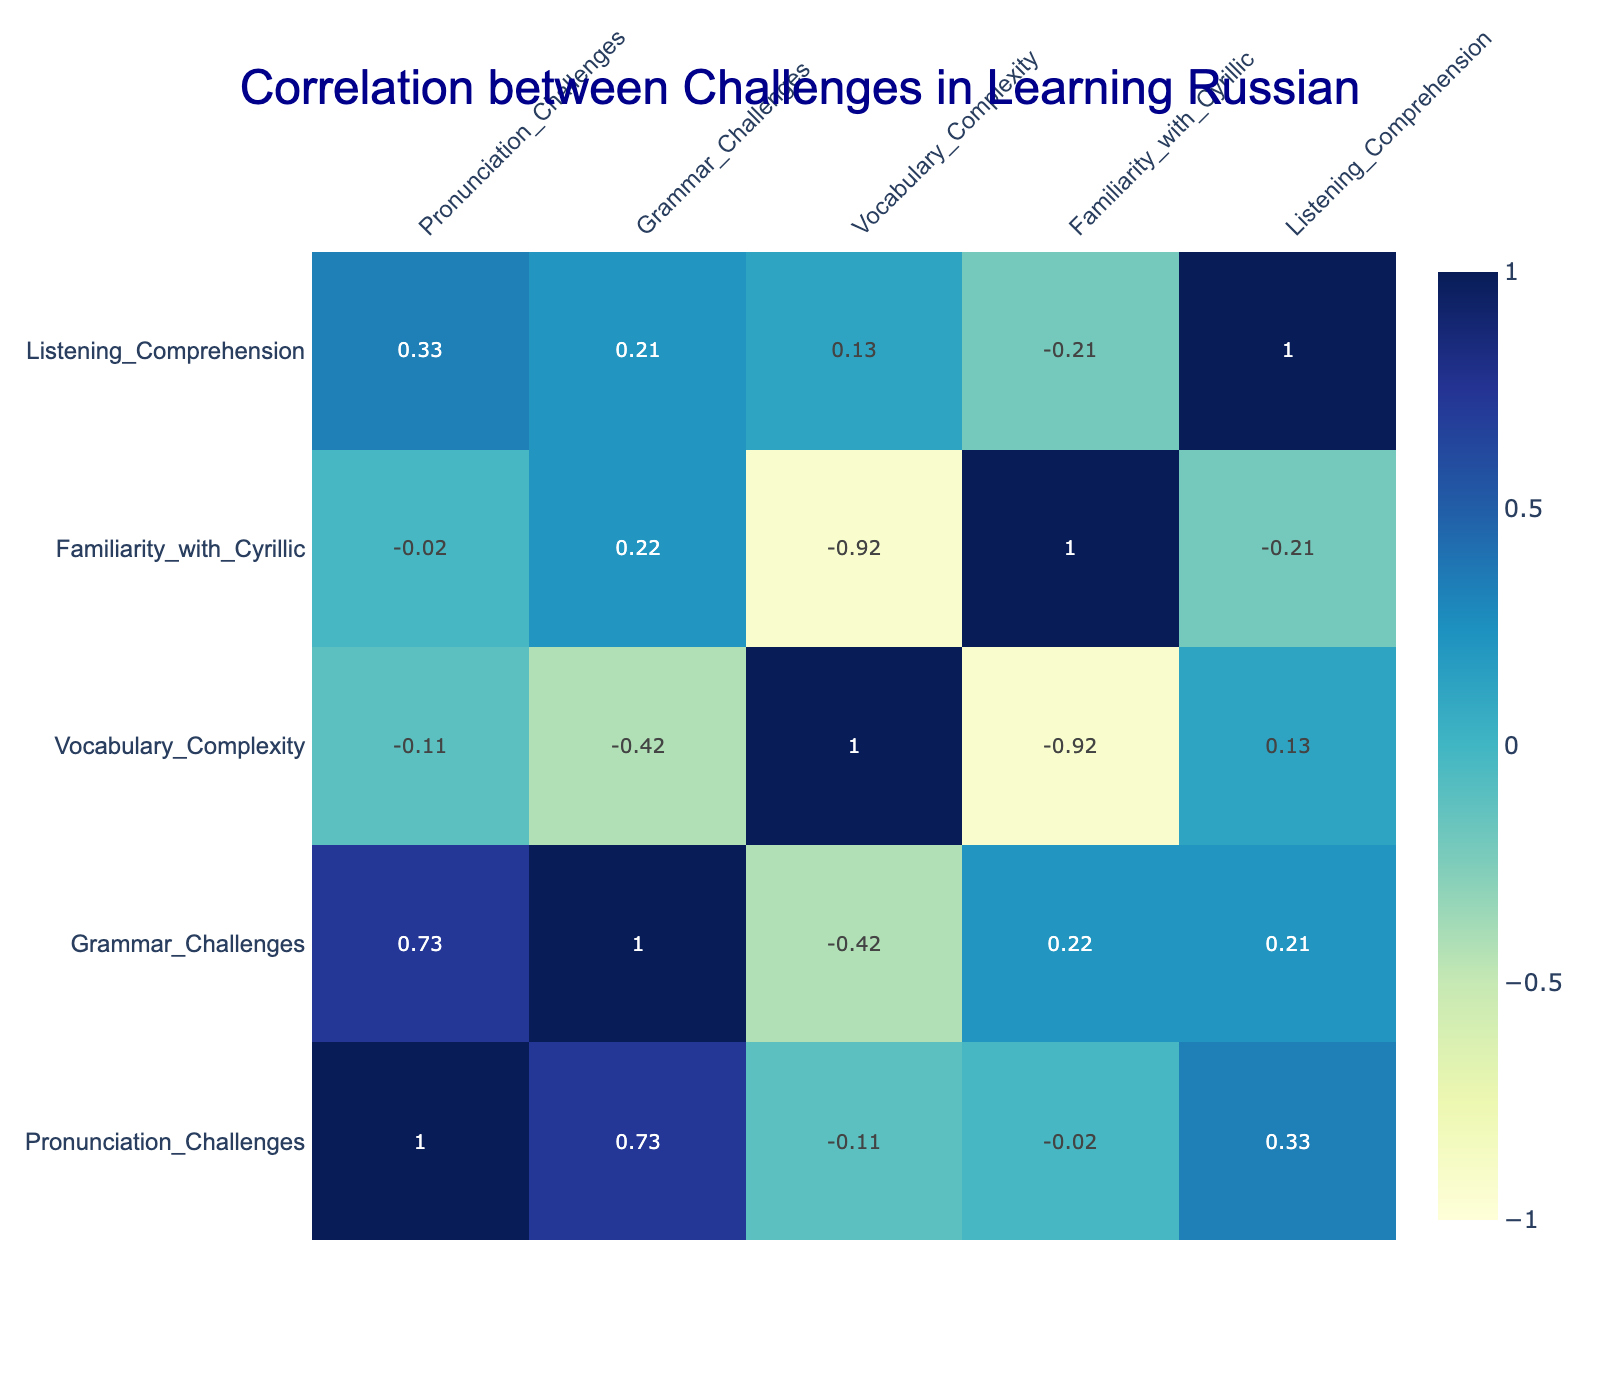What is the correlation between pronunciation challenges and grammar challenges? To find the correlation, look at the corresponding values in the table. The correlation is positive, suggesting that if one faces high pronunciation challenges, they likely also face high grammar challenges. Referring to the correlation table, the correlation value between these two factors is 0.66.
Answer: 0.66 Which native language has the highest vocabulary complexity? Compare the values for vocabulary complexity across all native languages listed. Arabic has the highest value with a score of 5, indicating that learners of Arabic face the most challenges with vocabulary complexity in learning Russian.
Answer: Arabic Is there a negative correlation between familiarity with Cyrillic and pronunciation challenges? From the correlation table, we check the values for familiarity with Cyrillic and pronunciation challenges. The correlation value is -0.44, which indicates a moderate negative correlation, meaning higher familiarity with Cyrillic is associated with lower pronunciation challenges.
Answer: Yes What is the average grammar challenge score for European languages (English, Spanish, French, German, Italian, Portuguese)? To find the average, sum the grammar challenge scores of the European languages (4 + 3 + 4 + 2 + 3 + 3 = 19) and divide by the number of languages (6). The average score is therefore 19 / 6, which equals approximately 3.17.
Answer: 3.17 Do Japanese learners face more listening comprehension challenges than Chinese learners? Looking at the listening comprehension scores, Japanese has a score of 2, while Chinese has a score of 5. Therefore, Japanese learners do not face more challenges compared to Chinese learners.
Answer: No Which native language exhibits the strongest correlation between vocabulary complexity and listening comprehension? We examine the correlation values for vocabulary complexity and listening comprehension. Checking the table values shows a correlation value of 0.45 between these two factors, indicating a moderate positive correlation. This is the strongest observed in the data.
Answer: 0.45 What is the difference in pronunciation challenge scores between Arabic and German learners? The pronunciation scores for Arabic and German are 5 and 2, respectively. To find the difference, subtract the German score from the Arabic score (5 - 2 = 3). Therefore, Arabic learners face 3 more challenges in pronunciation than German learners.
Answer: 3 Are all native languages represented in the table associated with some level of familiarity with Cyrillic? By checking the familiarity with Cyrillic scores for each language, all entries score between 2 and 4. Therefore, yes, every language in the table has some level of familiarity with Cyrillic.
Answer: Yes 